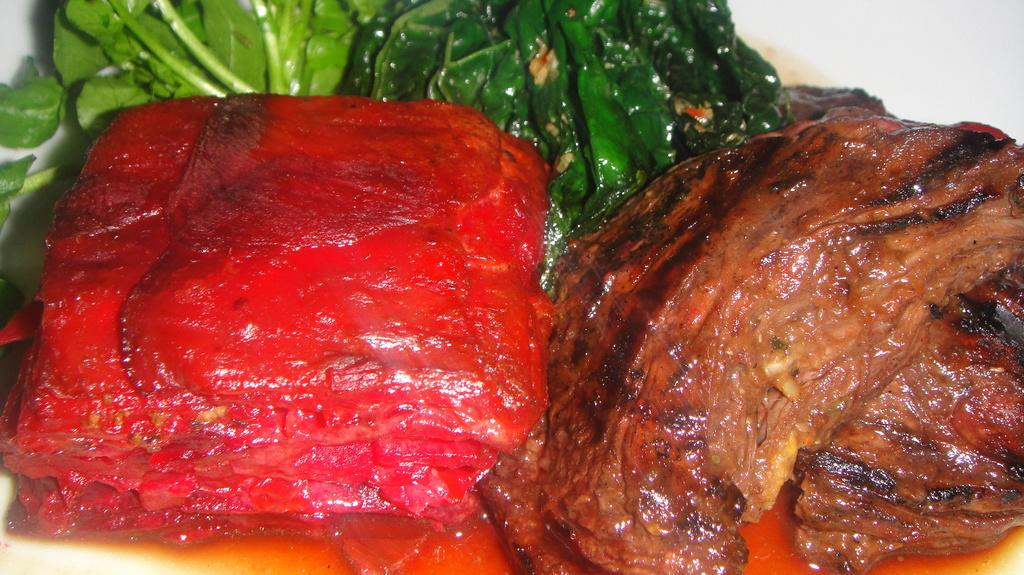What is present on the plate in the image? The plate contains food items. Can you describe the food items on the plate? Unfortunately, the specific food items cannot be determined from the provided facts. What might be used to serve or hold the food items on the plate? The plate itself is used to serve or hold the food items. What store can be seen in the background of the image? There is no store present in the image. 